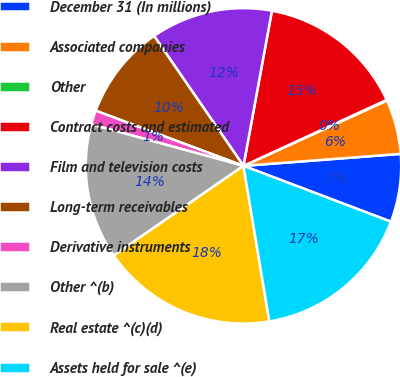<chart> <loc_0><loc_0><loc_500><loc_500><pie_chart><fcel>December 31 (In millions)<fcel>Associated companies<fcel>Other<fcel>Contract costs and estimated<fcel>Film and television costs<fcel>Long-term receivables<fcel>Derivative instruments<fcel>Other ^(b)<fcel>Real estate ^(c)(d)<fcel>Assets held for sale ^(e)<nl><fcel>6.97%<fcel>5.59%<fcel>0.07%<fcel>15.24%<fcel>12.48%<fcel>9.72%<fcel>1.45%<fcel>13.86%<fcel>18.0%<fcel>16.62%<nl></chart> 